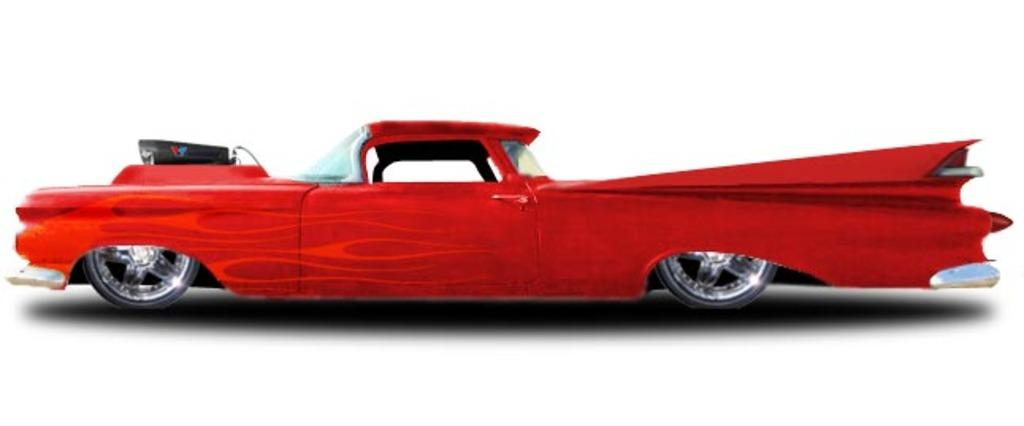What color is the car in the image? The car in the image is red. Can you see any lace on the car in the image? There is no lace present on the car in the image, as it is a red color car. 